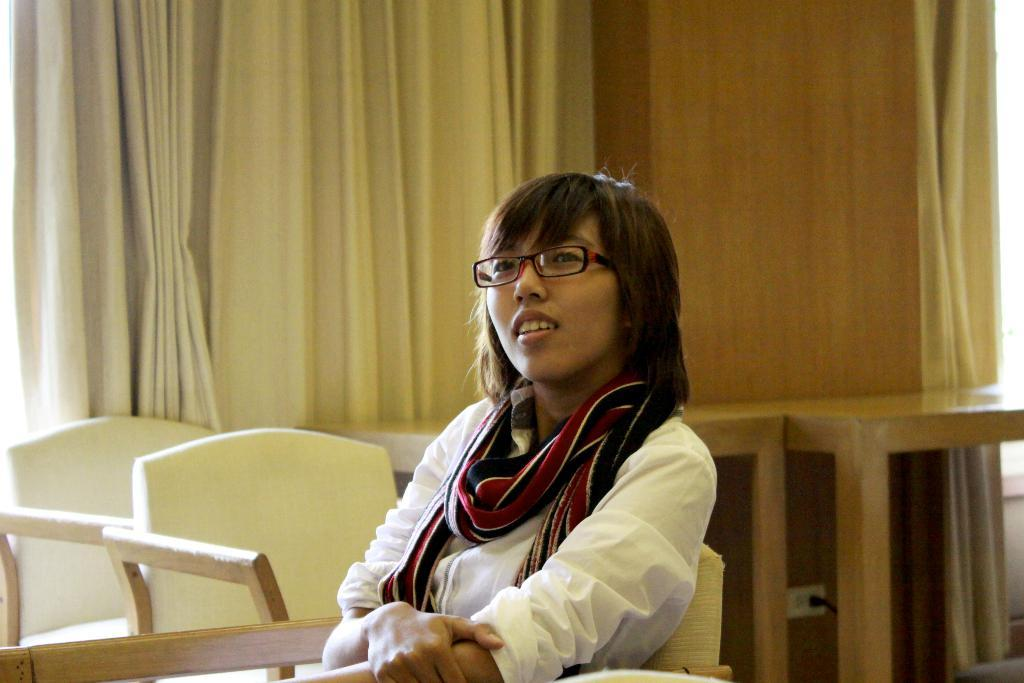Who is present in the image? There is a woman in the image. What is the woman wearing on her head? The woman is wearing a scarf. What accessory is the woman wearing on her face? The woman is wearing spectacles. What piece of furniture is the woman sitting on? The woman is sitting on a chair. What other furniture is visible near the woman? There are chairs and tables beside the woman. What can be seen in the background of the image? There is a wall and curtains in the background of the image. What is the woman's annual income in the image? There is no information about the woman's income in the image. What is the mass of the chair the woman is sitting on? The mass of the chair is not mentioned in the image. 